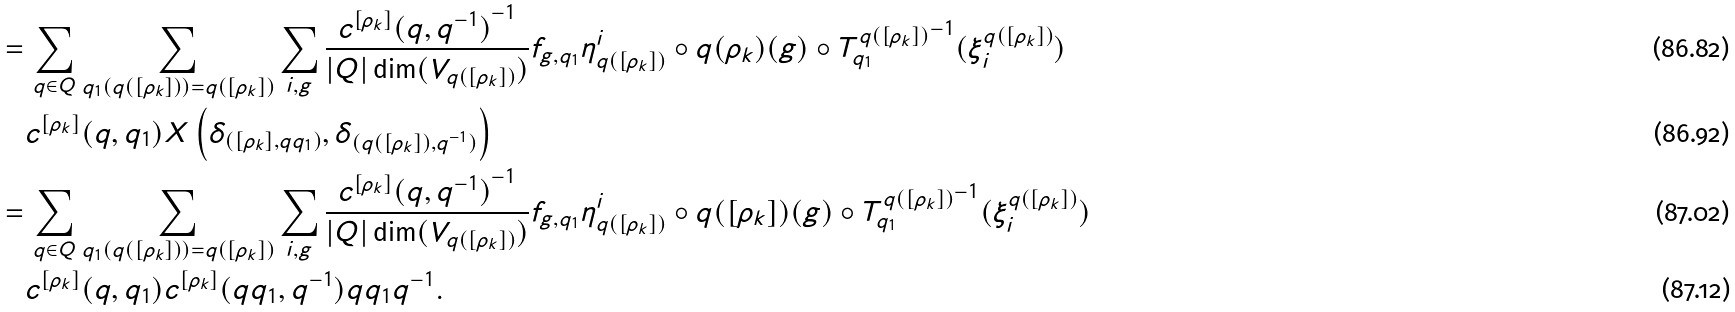Convert formula to latex. <formula><loc_0><loc_0><loc_500><loc_500>& = \sum _ { q \in Q } \sum _ { q _ { 1 } ( q ( [ \rho _ { k } ] ) ) = q ( [ \rho _ { k } ] ) } \sum _ { i , g } \frac { { c ^ { [ \rho _ { k } ] } ( q , q ^ { - 1 } ) } ^ { - 1 } } { | Q | \dim ( V _ { q ( [ \rho _ { k } ] ) } ) } f _ { g , q _ { 1 } } \eta ^ { i } _ { q ( [ \rho _ { k } ] ) } \circ q ( \rho _ { k } ) ( g ) \circ { T ^ { q ( [ \rho _ { k } ] ) } _ { q _ { 1 } } } ^ { - 1 } ( \xi ^ { q ( [ \rho _ { k } ] ) } _ { i } ) \\ & \quad c ^ { [ \rho _ { k } ] } ( q , q _ { 1 } ) X \left ( \delta _ { ( [ \rho _ { k } ] , q q _ { 1 } ) } , \delta _ { ( q ( [ \rho _ { k } ] ) , q ^ { - 1 } ) } \right ) \\ & = \sum _ { q \in Q } \sum _ { q _ { 1 } ( q ( [ \rho _ { k } ] ) ) = q ( [ \rho _ { k } ] ) } \sum _ { i , g } \frac { { c ^ { [ \rho _ { k } ] } ( q , q ^ { - 1 } ) } ^ { - 1 } } { | Q | \dim ( V _ { q ( [ \rho _ { k } ] ) } ) } f _ { g , q _ { 1 } } \eta ^ { i } _ { q ( [ \rho _ { k } ] ) } \circ q ( [ \rho _ { k } ] ) ( g ) \circ { T ^ { q ( [ \rho _ { k } ] ) } _ { q _ { 1 } } } ^ { - 1 } ( \xi ^ { q ( [ \rho _ { k } ] ) } _ { i } ) \\ & \quad c ^ { [ \rho _ { k } ] } ( q , q _ { 1 } ) c ^ { [ \rho _ { k } ] } ( q q _ { 1 } , q ^ { - 1 } ) q q _ { 1 } q ^ { - 1 } .</formula> 